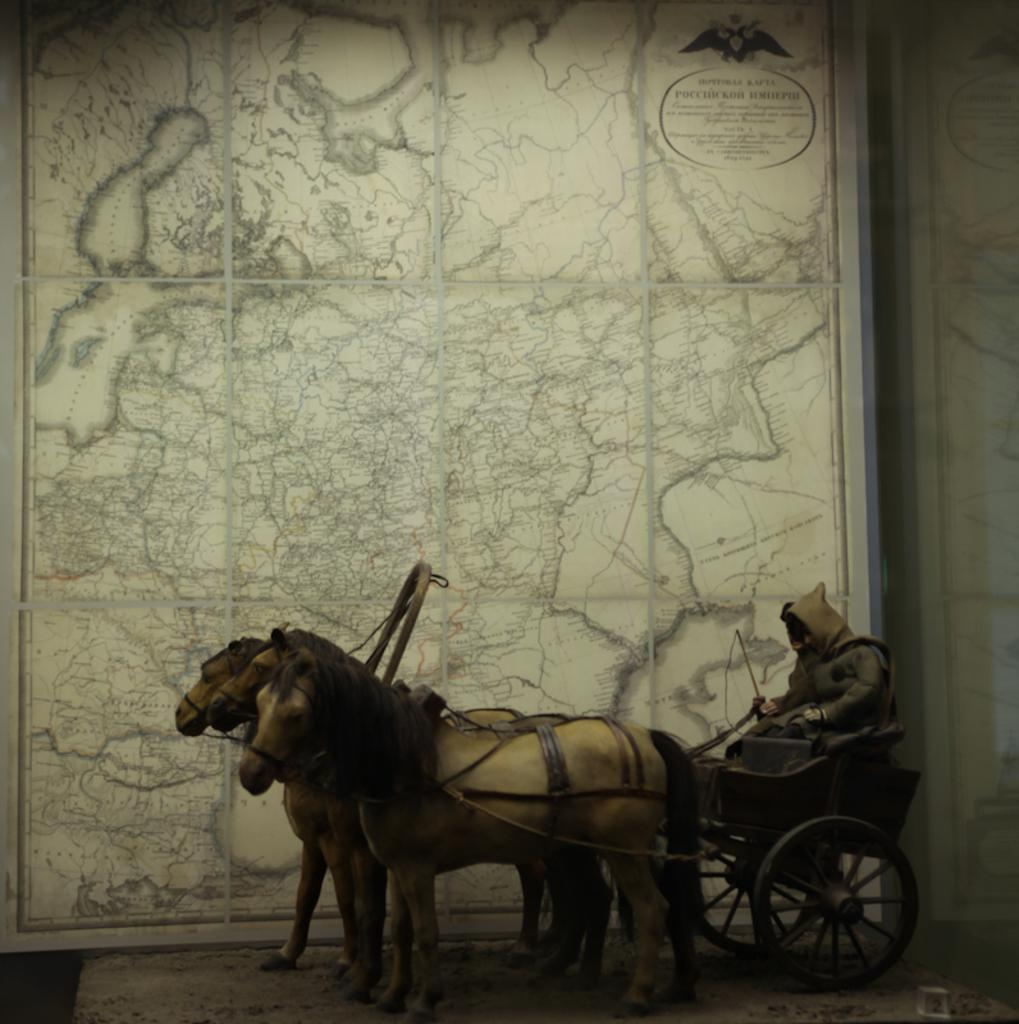What is the main subject of the image? The main subject of the image is a sculpture. What is the sculpture depicting? The sculpture depicts a guy riding three horses. What can be seen in the background of the image? There is a decorated wall in the background of the image. Can you tell me how many kittens are sitting on the guy's lap in the sculpture? There are no kittens present in the sculpture; it depicts a guy riding three horses. What type of smile can be seen on the guy's face in the sculpture? The sculpture does not have a face or any expression, as it is a depiction of a guy riding horses. 